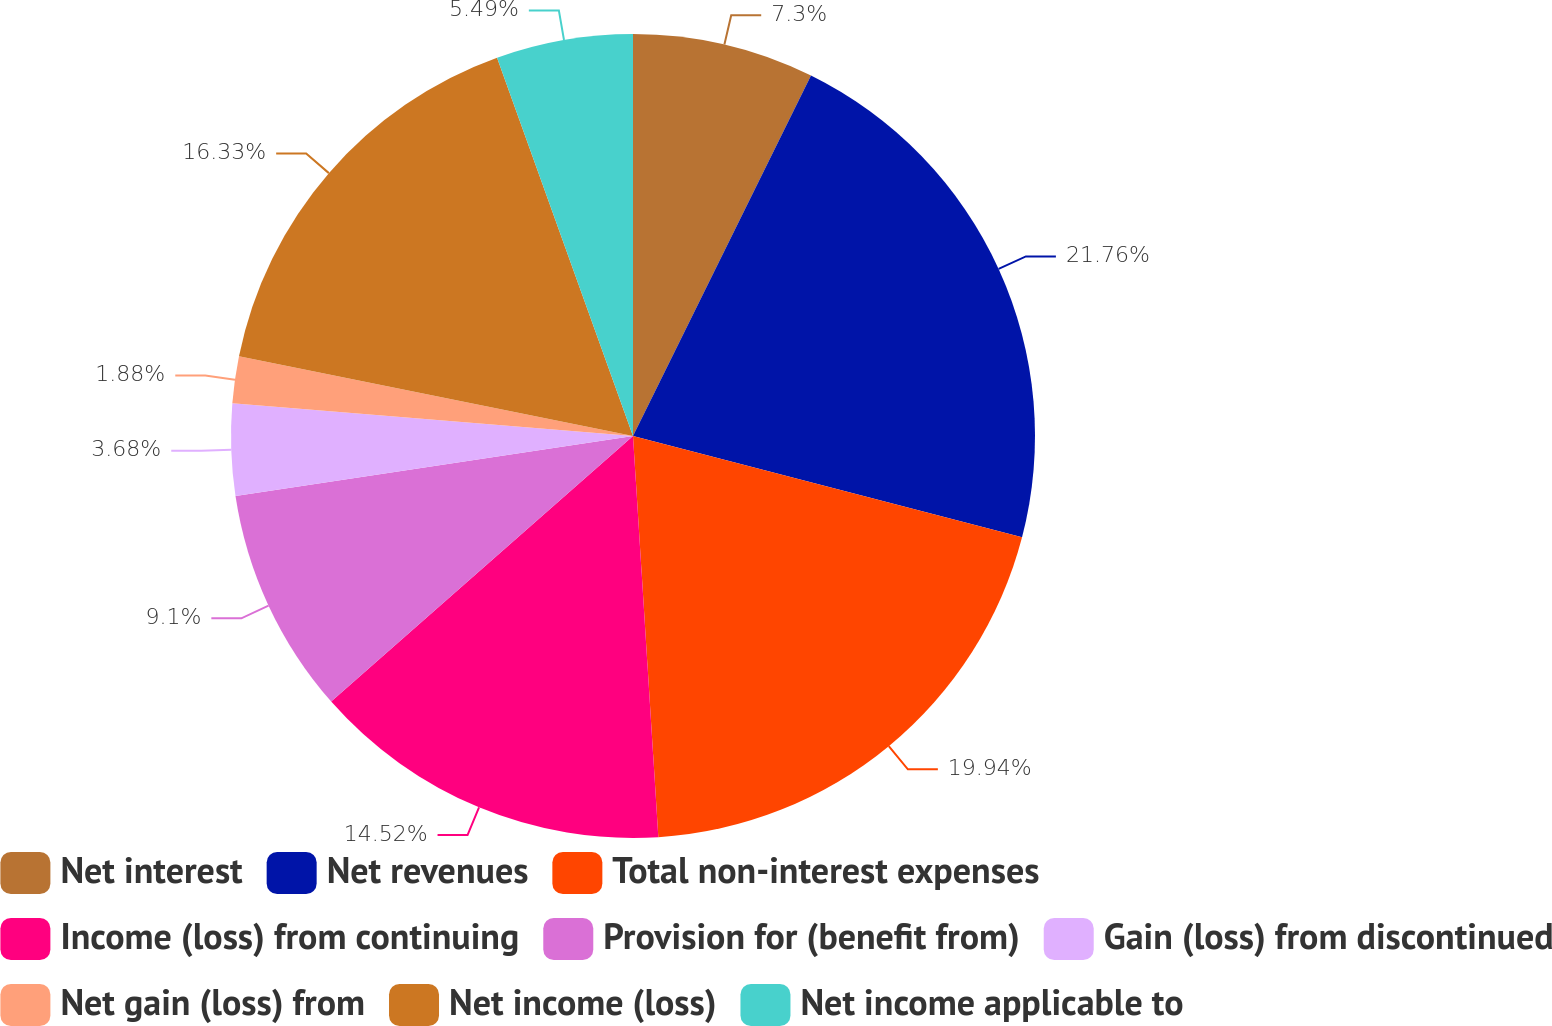Convert chart to OTSL. <chart><loc_0><loc_0><loc_500><loc_500><pie_chart><fcel>Net interest<fcel>Net revenues<fcel>Total non-interest expenses<fcel>Income (loss) from continuing<fcel>Provision for (benefit from)<fcel>Gain (loss) from discontinued<fcel>Net gain (loss) from<fcel>Net income (loss)<fcel>Net income applicable to<nl><fcel>7.3%<fcel>21.75%<fcel>19.94%<fcel>14.52%<fcel>9.1%<fcel>3.68%<fcel>1.88%<fcel>16.33%<fcel>5.49%<nl></chart> 